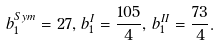Convert formula to latex. <formula><loc_0><loc_0><loc_500><loc_500>b _ { 1 } ^ { S y m } = 2 7 , \, b _ { 1 } ^ { I } = \frac { 1 0 5 } { 4 } , \, b _ { 1 } ^ { I I } = \frac { 7 3 } { 4 } .</formula> 